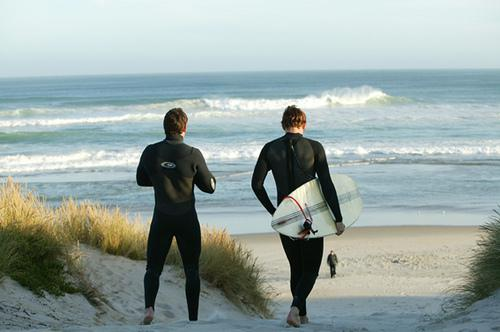Question: what are the men doing?
Choices:
A. Jogging around the track.
B. Walking down the sidewalk.
C. Walking on the beach.
D. Playing with a frisbee.
Answer with the letter. Answer: C Question: what are the men wearing on their feet?
Choices:
A. Nothing.
B. Flip flops.
C. Tennis shoes.
D. Sandals.
Answer with the letter. Answer: A Question: where was this photo taken?
Choices:
A. In the mountains.
B. In the country.
C. In the jungle.
D. On the beach.
Answer with the letter. Answer: D Question: what is the man on the right carrying?
Choices:
A. A surfboard.
B. A snowboard.
C. Snow skis.
D. Water skis.
Answer with the letter. Answer: A Question: what color is the ocean in the photo?
Choices:
A. Green.
B. White.
C. Blue.
D. Clear.
Answer with the letter. Answer: C Question: who is featured in this photo?
Choices:
A. Two men.
B. Three women.
C. Four girls.
D. Five boys.
Answer with the letter. Answer: A 